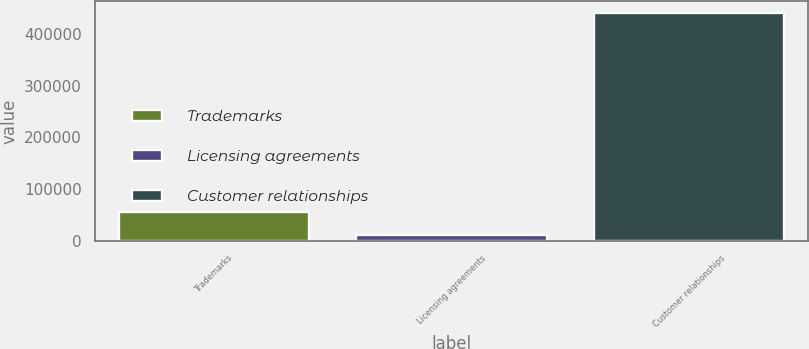Convert chart. <chart><loc_0><loc_0><loc_500><loc_500><bar_chart><fcel>Trademarks<fcel>Licensing agreements<fcel>Customer relationships<nl><fcel>54678.8<fcel>11729<fcel>441227<nl></chart> 